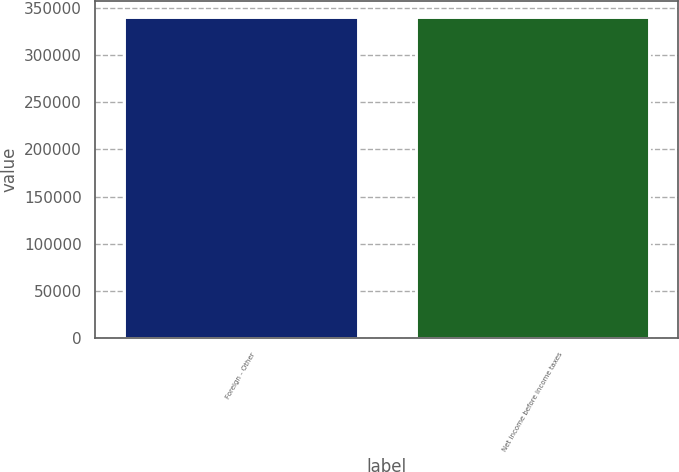Convert chart to OTSL. <chart><loc_0><loc_0><loc_500><loc_500><bar_chart><fcel>Foreign - Other<fcel>Net income before income taxes<nl><fcel>340334<fcel>340334<nl></chart> 